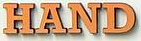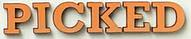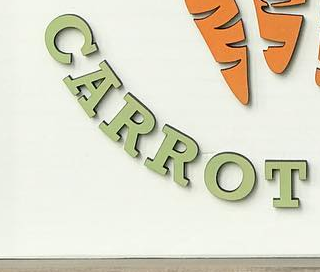Transcribe the words shown in these images in order, separated by a semicolon. HAND; PICKED; CARROT 